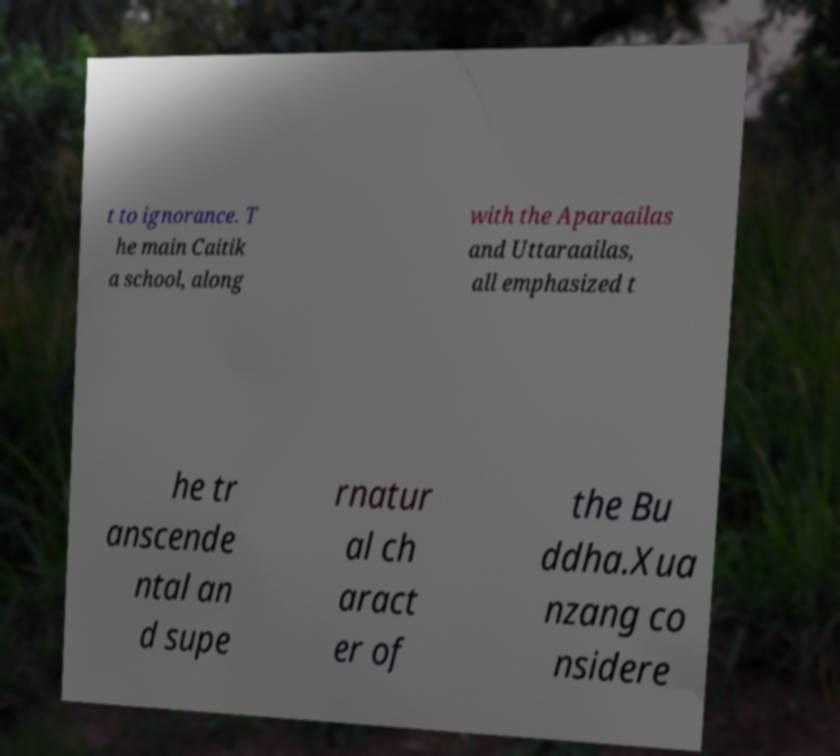Can you read and provide the text displayed in the image?This photo seems to have some interesting text. Can you extract and type it out for me? t to ignorance. T he main Caitik a school, along with the Aparaailas and Uttaraailas, all emphasized t he tr anscende ntal an d supe rnatur al ch aract er of the Bu ddha.Xua nzang co nsidere 